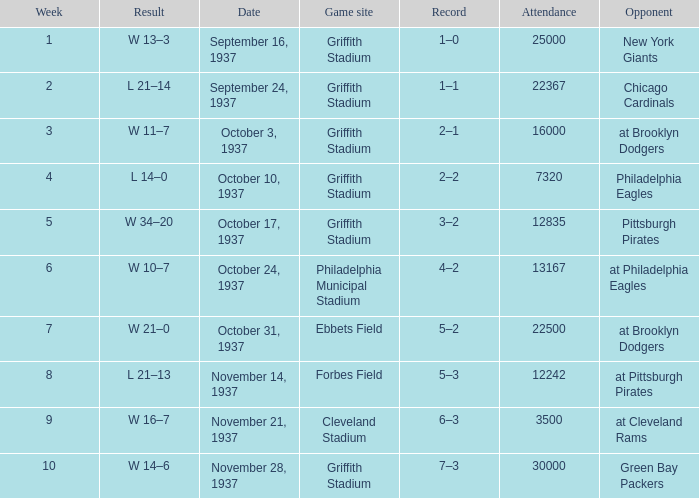On October 17, 1937 what was maximum number or attendants. 12835.0. 